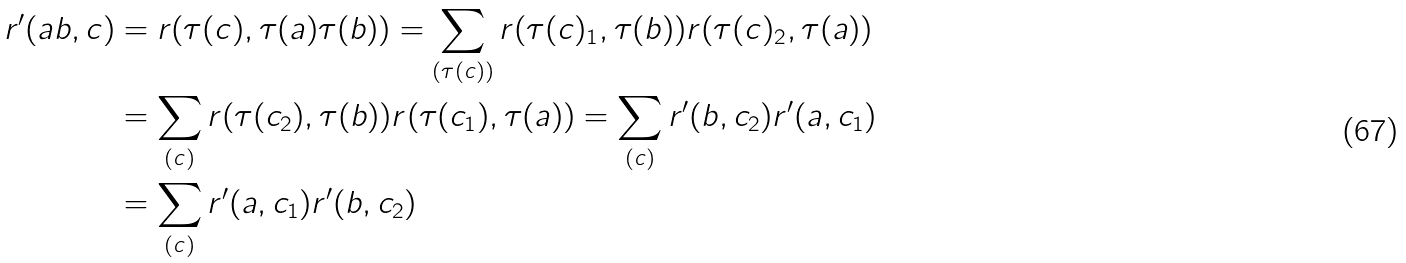Convert formula to latex. <formula><loc_0><loc_0><loc_500><loc_500>r ^ { \prime } ( a b , c ) & = r ( \tau ( c ) , \tau ( a ) \tau ( b ) ) = \sum _ { ( \tau ( c ) ) } r ( \tau ( c ) _ { 1 } , \tau ( b ) ) r ( \tau ( c ) _ { 2 } , \tau ( a ) ) \\ & = \sum _ { ( c ) } r ( \tau ( c _ { 2 } ) , \tau ( b ) ) r ( \tau ( c _ { 1 } ) , \tau ( a ) ) = \sum _ { ( c ) } r ^ { \prime } ( b , c _ { 2 } ) r ^ { \prime } ( a , c _ { 1 } ) \\ & = \sum _ { ( c ) } r ^ { \prime } ( a , c _ { 1 } ) r ^ { \prime } ( b , c _ { 2 } )</formula> 